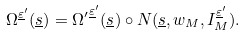<formula> <loc_0><loc_0><loc_500><loc_500>\Omega ^ { \underline { \varepsilon } ^ { \prime } } ( \underline { s } ) = { \Omega ^ { \prime } } ^ { \underline { \varepsilon } ^ { \prime } } ( \underline { s } ) \circ N ( \underline { s } , w _ { M } , I _ { M } ^ { \underline { \varepsilon } ^ { \prime } } ) .</formula> 